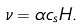Convert formula to latex. <formula><loc_0><loc_0><loc_500><loc_500>\nu = \alpha c _ { s } H .</formula> 